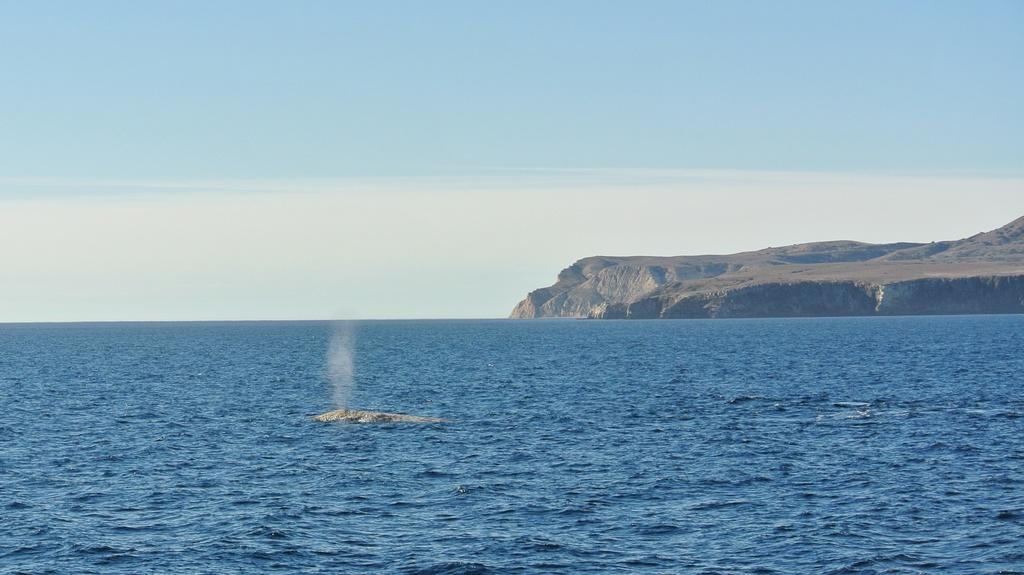What is present at the bottom of the image? There is water at the bottom of the image. What can be seen in the background of the image? There is a hill in the background of the image. What is visible at the top of the image? The sky is visible at the top of the image. How many oranges are hanging from the hill in the image? There are no oranges present in the image; it features water at the bottom and a hill in the background. What type of rock is visible on the hill in the image? There is no rock visible on the hill in the image; it is a general representation of a hill. 